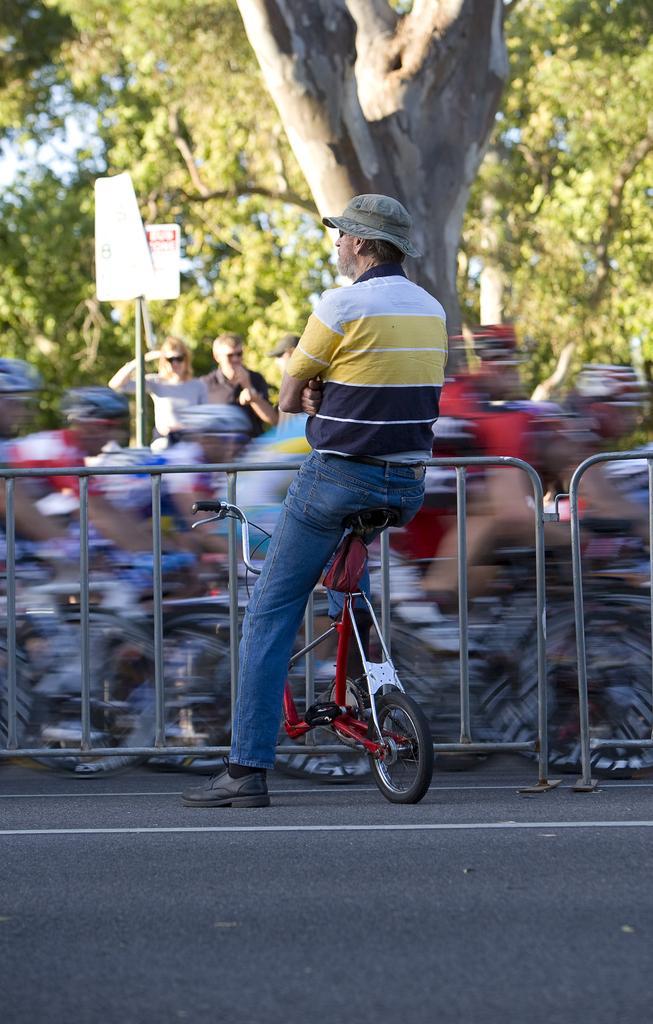Describe this image in one or two sentences. In this image I can see the person sitting on the bicycle, the person is wearing yellow, black and blue color dress. Background I can see the railing and few persons standing, trees in green color and the sky is in white color. 